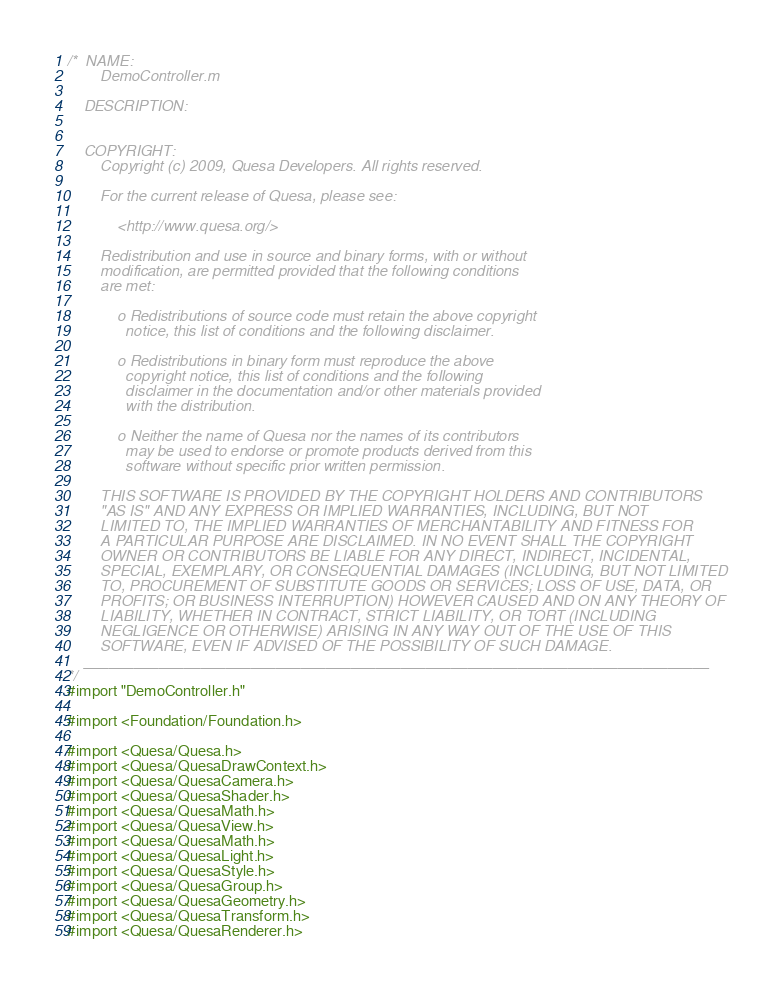Convert code to text. <code><loc_0><loc_0><loc_500><loc_500><_ObjectiveC_>/*  NAME:
        DemoController.m

    DESCRIPTION:
        

    COPYRIGHT:
        Copyright (c) 2009, Quesa Developers. All rights reserved.

        For the current release of Quesa, please see:

            <http://www.quesa.org/>
        
        Redistribution and use in source and binary forms, with or without
        modification, are permitted provided that the following conditions
        are met:
        
            o Redistributions of source code must retain the above copyright
              notice, this list of conditions and the following disclaimer.
        
            o Redistributions in binary form must reproduce the above
              copyright notice, this list of conditions and the following
              disclaimer in the documentation and/or other materials provided
              with the distribution.
        
            o Neither the name of Quesa nor the names of its contributors
              may be used to endorse or promote products derived from this
              software without specific prior written permission.
        
        THIS SOFTWARE IS PROVIDED BY THE COPYRIGHT HOLDERS AND CONTRIBUTORS
        "AS IS" AND ANY EXPRESS OR IMPLIED WARRANTIES, INCLUDING, BUT NOT
        LIMITED TO, THE IMPLIED WARRANTIES OF MERCHANTABILITY AND FITNESS FOR
        A PARTICULAR PURPOSE ARE DISCLAIMED. IN NO EVENT SHALL THE COPYRIGHT
        OWNER OR CONTRIBUTORS BE LIABLE FOR ANY DIRECT, INDIRECT, INCIDENTAL,
        SPECIAL, EXEMPLARY, OR CONSEQUENTIAL DAMAGES (INCLUDING, BUT NOT LIMITED
        TO, PROCUREMENT OF SUBSTITUTE GOODS OR SERVICES; LOSS OF USE, DATA, OR
        PROFITS; OR BUSINESS INTERRUPTION) HOWEVER CAUSED AND ON ANY THEORY OF
        LIABILITY, WHETHER IN CONTRACT, STRICT LIABILITY, OR TORT (INCLUDING
        NEGLIGENCE OR OTHERWISE) ARISING IN ANY WAY OUT OF THE USE OF THIS
        SOFTWARE, EVEN IF ADVISED OF THE POSSIBILITY OF SUCH DAMAGE.
    ___________________________________________________________________________
*/
#import "DemoController.h"

#import <Foundation/Foundation.h>

#import <Quesa/Quesa.h>
#import <Quesa/QuesaDrawContext.h>
#import <Quesa/QuesaCamera.h>
#import <Quesa/QuesaShader.h>
#import <Quesa/QuesaMath.h>
#import <Quesa/QuesaView.h>
#import <Quesa/QuesaMath.h>
#import <Quesa/QuesaLight.h>
#import <Quesa/QuesaStyle.h> 
#import <Quesa/QuesaGroup.h> 
#import <Quesa/QuesaGeometry.h> 
#import <Quesa/QuesaTransform.h> 
#import <Quesa/QuesaRenderer.h>
</code> 